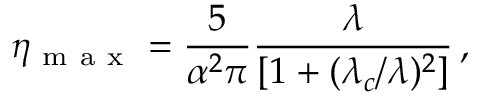<formula> <loc_0><loc_0><loc_500><loc_500>\eta _ { m a x } = \frac { 5 } { \alpha ^ { 2 } \pi } \frac { \lambda } { [ 1 + ( \lambda _ { c } / \lambda ) ^ { 2 } ] } \, ,</formula> 